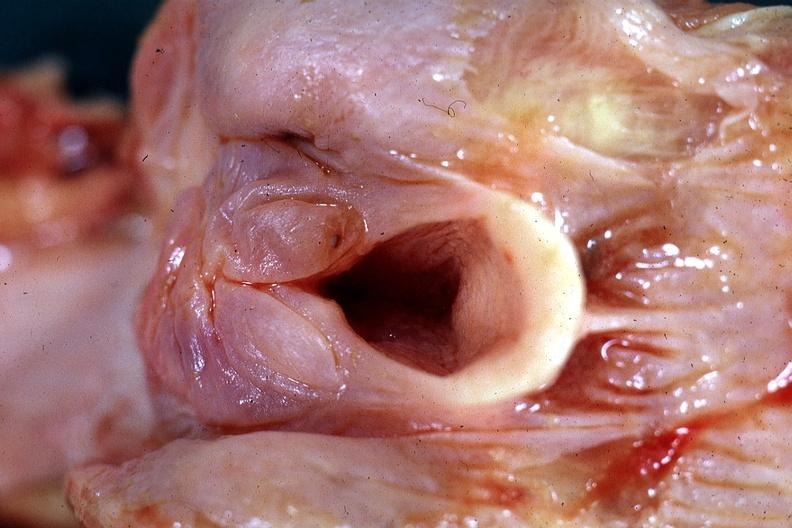where is this?
Answer the question using a single word or phrase. Oral 